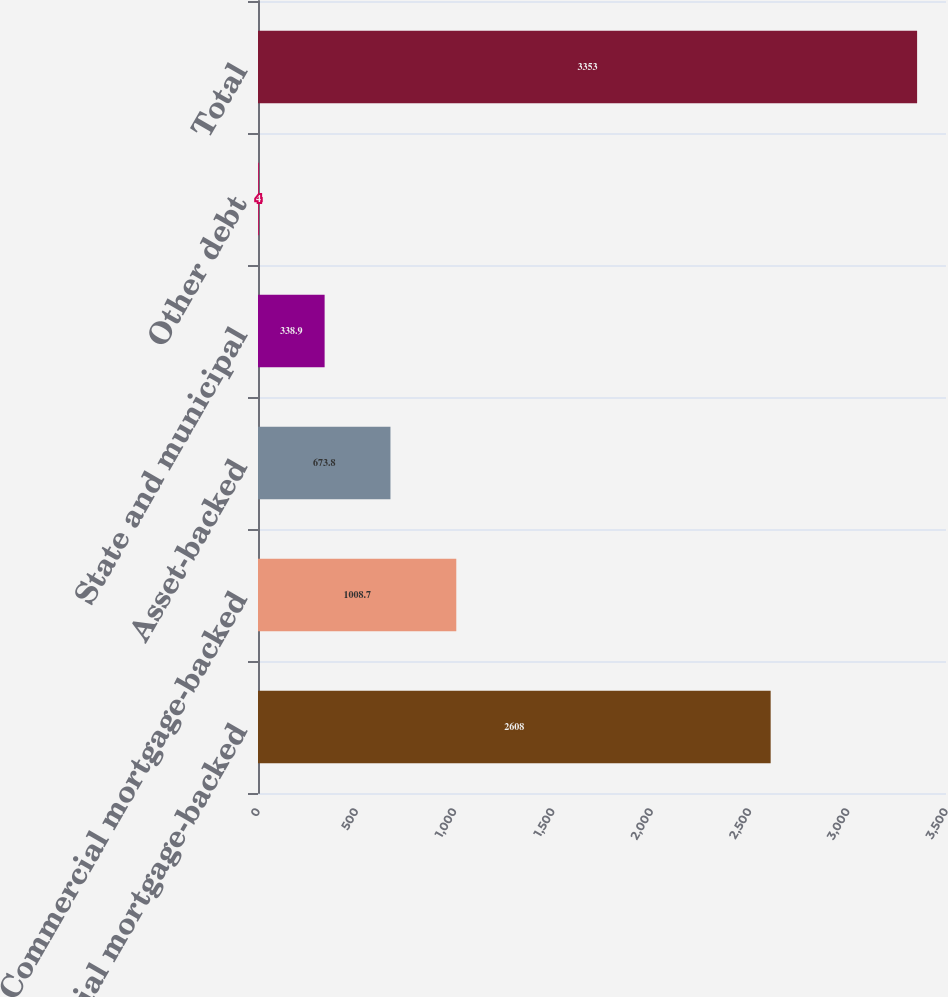Convert chart. <chart><loc_0><loc_0><loc_500><loc_500><bar_chart><fcel>Residential mortgage-backed<fcel>Commercial mortgage-backed<fcel>Asset-backed<fcel>State and municipal<fcel>Other debt<fcel>Total<nl><fcel>2608<fcel>1008.7<fcel>673.8<fcel>338.9<fcel>4<fcel>3353<nl></chart> 